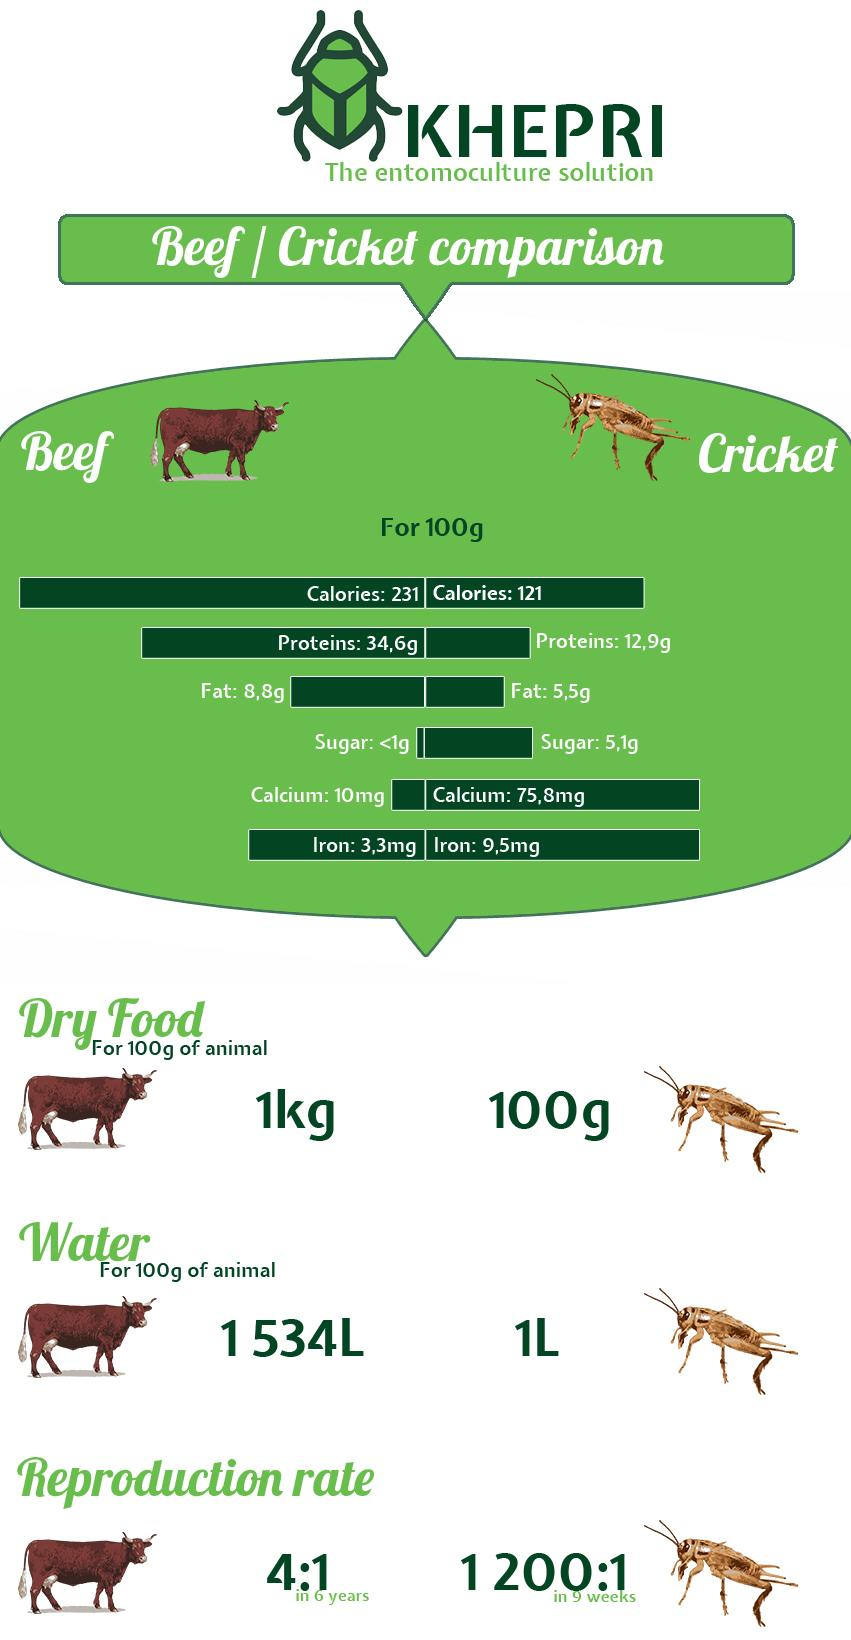Outline some significant characteristics in this image. The fat content in 100 grams of beef is three times higher than the fat content in 100 grams of cricket. There is 9,5 milligrams of iron in 100 grams of cricket. The amount of calories in 100 grams of cricket is 121 calories. The amount of calories in 100 grams of beef is 231 calories. The reproduction period of crickets is 9 weeks. 